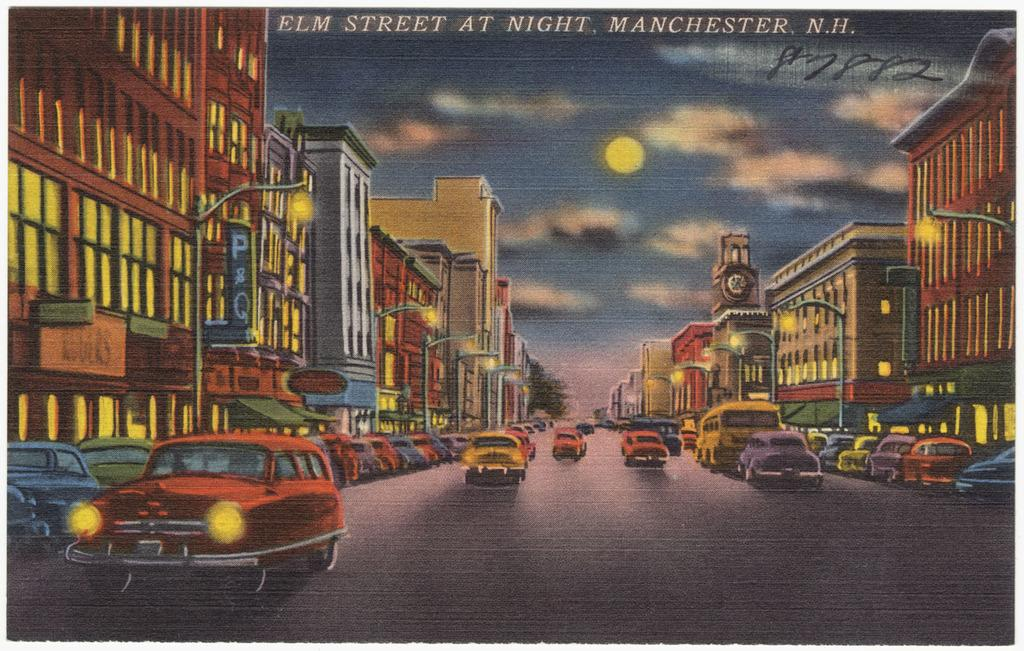<image>
Create a compact narrative representing the image presented. Cars go by on a busy city street in Manchester, N.H. 